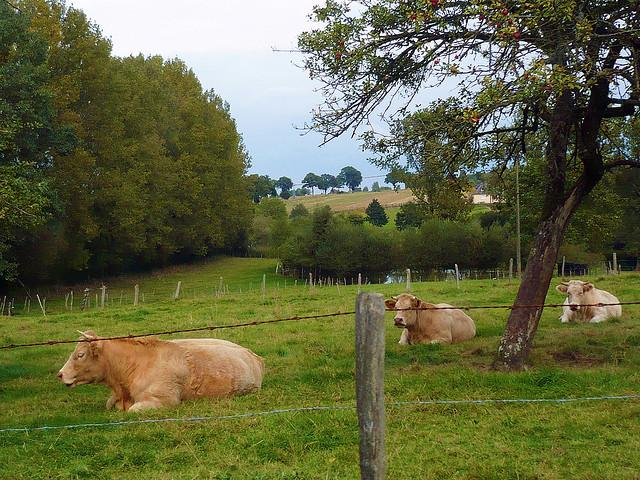What is strung on the fence to keep the cows in? wire 